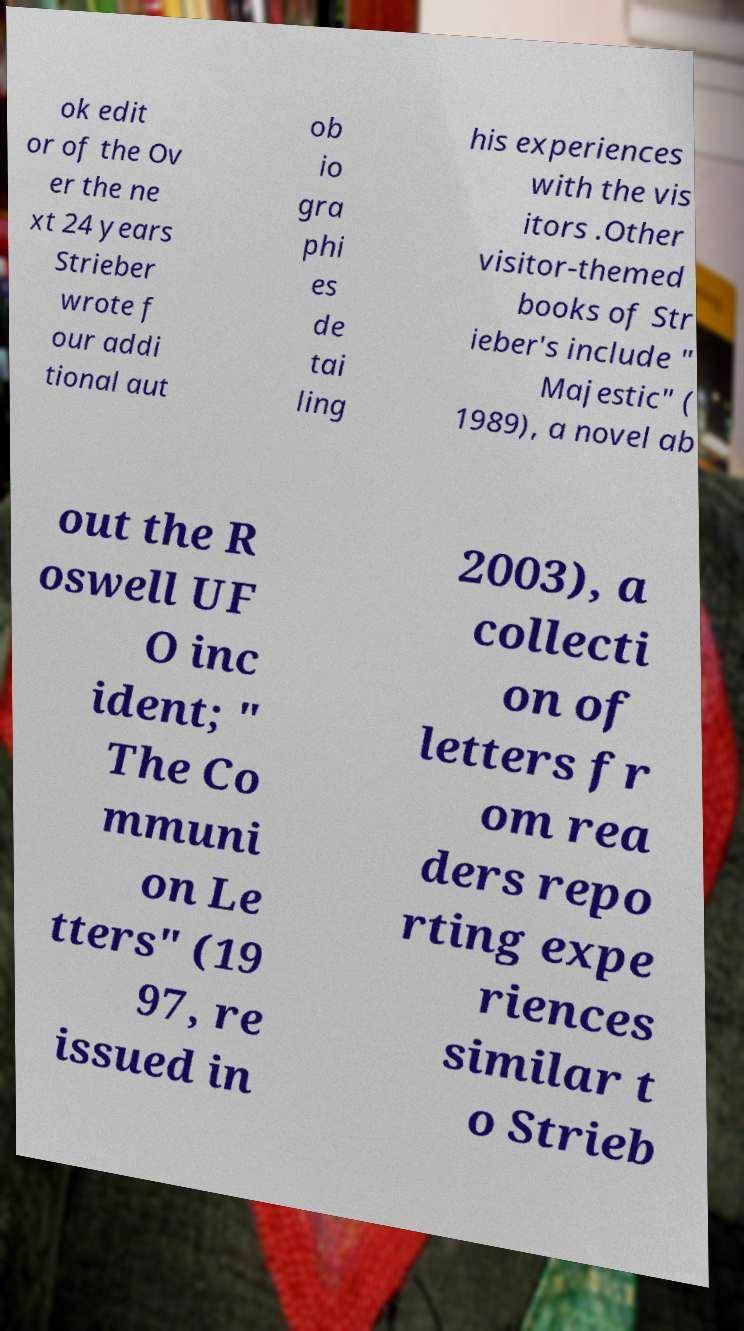For documentation purposes, I need the text within this image transcribed. Could you provide that? ok edit or of the Ov er the ne xt 24 years Strieber wrote f our addi tional aut ob io gra phi es de tai ling his experiences with the vis itors .Other visitor-themed books of Str ieber's include " Majestic" ( 1989), a novel ab out the R oswell UF O inc ident; " The Co mmuni on Le tters" (19 97, re issued in 2003), a collecti on of letters fr om rea ders repo rting expe riences similar t o Strieb 